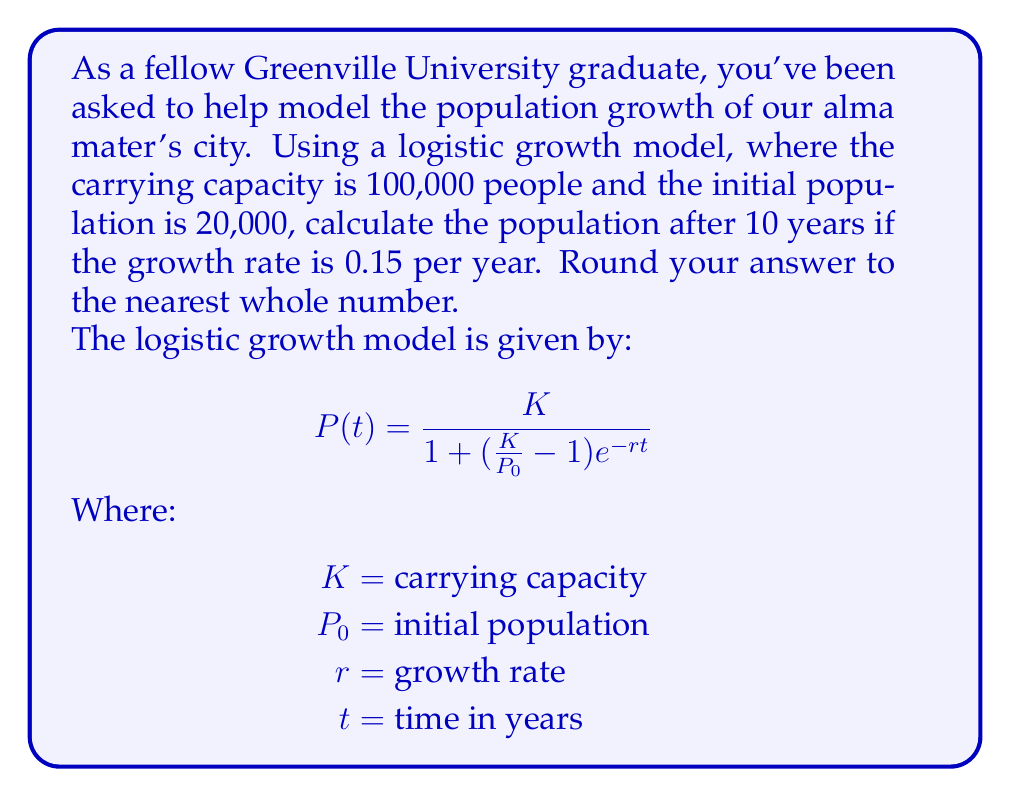Solve this math problem. Let's approach this step-by-step:

1) We're given the following values:
   $K = 100,000$ (carrying capacity)
   $P_0 = 20,000$ (initial population)
   $r = 0.15$ (growth rate)
   $t = 10$ (time in years)

2) Let's substitute these values into the logistic growth model:

   $$P(10) = \frac{100,000}{1 + (\frac{100,000}{20,000} - 1)e^{-0.15(10)}}$$

3) Simplify the fraction inside the parentheses:

   $$P(10) = \frac{100,000}{1 + (5 - 1)e^{-1.5}}$$

4) Simplify further:

   $$P(10) = \frac{100,000}{1 + 4e^{-1.5}}$$

5) Calculate $e^{-1.5}$:

   $$e^{-1.5} \approx 0.2231$$

6) Substitute this value:

   $$P(10) = \frac{100,000}{1 + 4(0.2231)}$$

7) Simplify:

   $$P(10) = \frac{100,000}{1 + 0.8924} = \frac{100,000}{1.8924}$$

8) Calculate the final result:

   $$P(10) \approx 52,844.22$$

9) Rounding to the nearest whole number:

   $$P(10) \approx 52,844$$
Answer: 52,844 